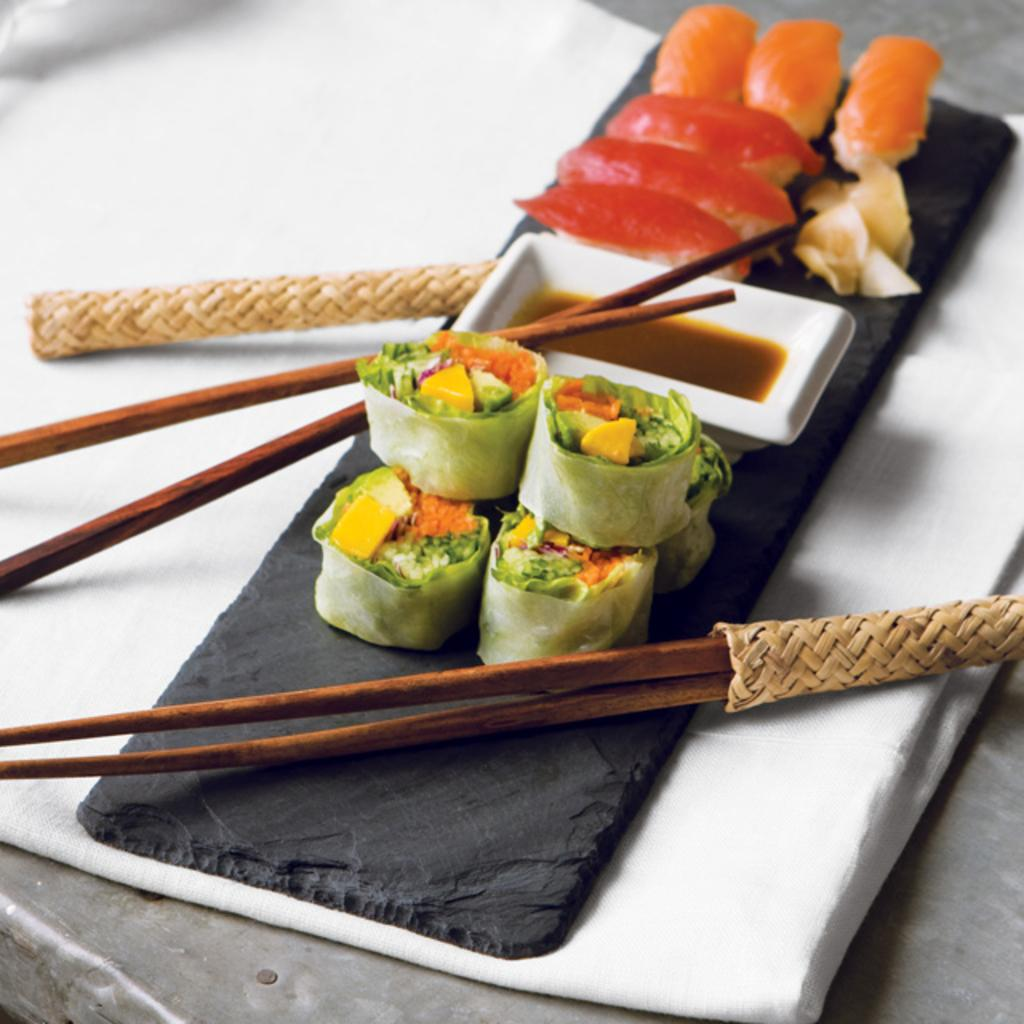What type of furniture is in the image? There is a table in the image. What is covering the table? There is a white cloth on the table. What is above the white cloth? There is a back cloth above the white cloth. What can be seen on the back cloth? Chopsticks, food items, and a bowl are present on the back cloth. What type of books are being discussed during the meeting in the image? There is no meeting or books present in the image; it features a table with a white cloth, a back cloth, and various items on it. 